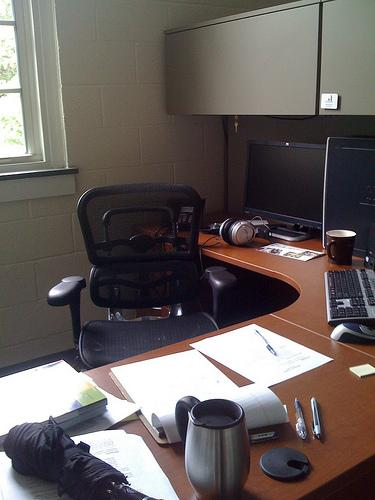Provide a brief description of the office setting, including the primary colors of the main objects and their arrangement. A black office chair is in front of a desk with a computer monitor, keyboard, mouse, and various items like mugs, pens, and papers in a neatly arranged manner on it. What is the most prominent furniture item in the image and provide a brief description of its appearance. The black office chair is the most prominent, with a tall backrest and situated in front of a desk. For the referential expression grounding task, describe the relative position of the pen and paper on the desk. The pen is on top of the white paper, which is placed on the desk. What type of electronic devices and accessories can be found in the image? A computer monitor, keyboard, mouse, and large headphones are present in the image. List three items on the desk and their relative positions to each other. A silver mug is beside a black umbrella, which is on top of white papers, and a brown mug is near the computer monitor. In a referential expression grounding task, describe the position of the black umbrella in relation to the desk. The black umbrella is placed on top of a stack of white papers, which is situated on the desk. Which two objects in the scene are used for providing audio input and output? Large headphones and a computer monitor provide audio input and output. What is the drinkware item with a metallic appearance in the image, and where is it located? A silver mug is on the wooden desk. Name three items in the image that are related to writing or note-taking. Pen, paper, and legal notepad on a clipboard. In the context of product advertisement, describe a scenario where the items in this image are being promoted in a commercial. Imagine working in a cozy home office furnished with a comfortable black chair, advanced computer setup, and essential accessories like a keyboard, mouse, and headphones, surrounded by convenient essentials such as mugs, pens, and papers for a productive work experience. 